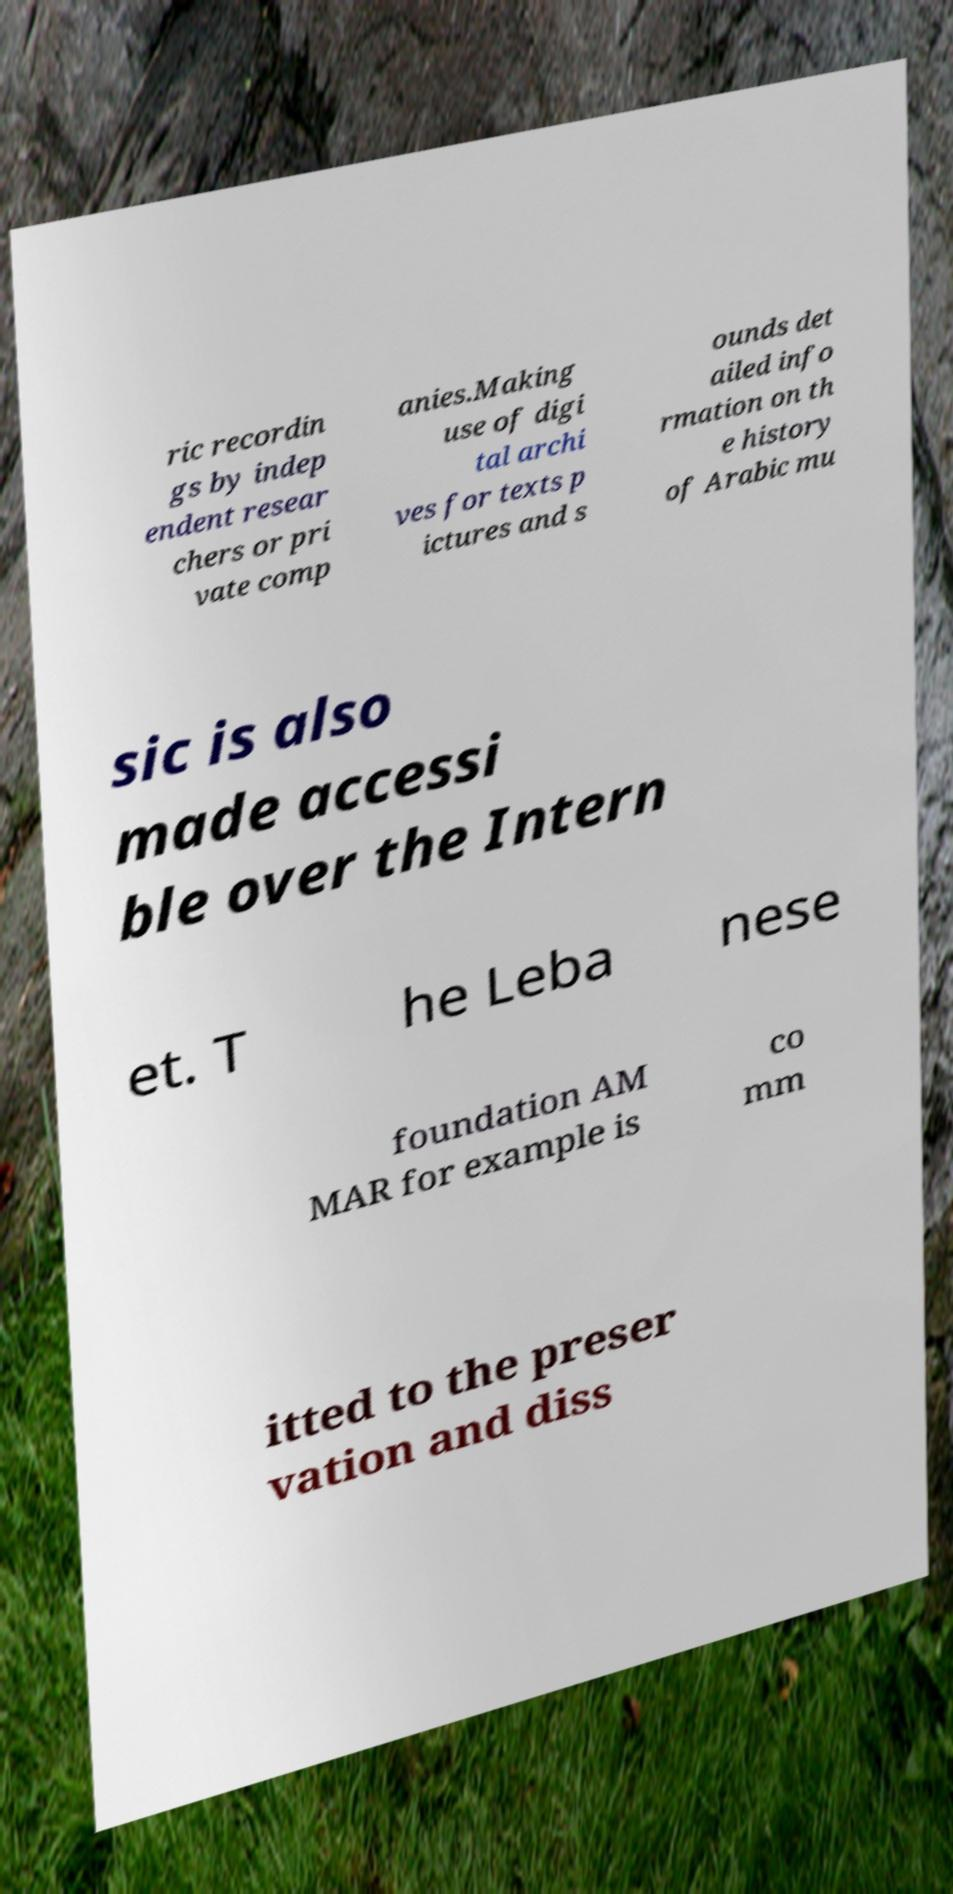Please read and relay the text visible in this image. What does it say? ric recordin gs by indep endent resear chers or pri vate comp anies.Making use of digi tal archi ves for texts p ictures and s ounds det ailed info rmation on th e history of Arabic mu sic is also made accessi ble over the Intern et. T he Leba nese foundation AM MAR for example is co mm itted to the preser vation and diss 